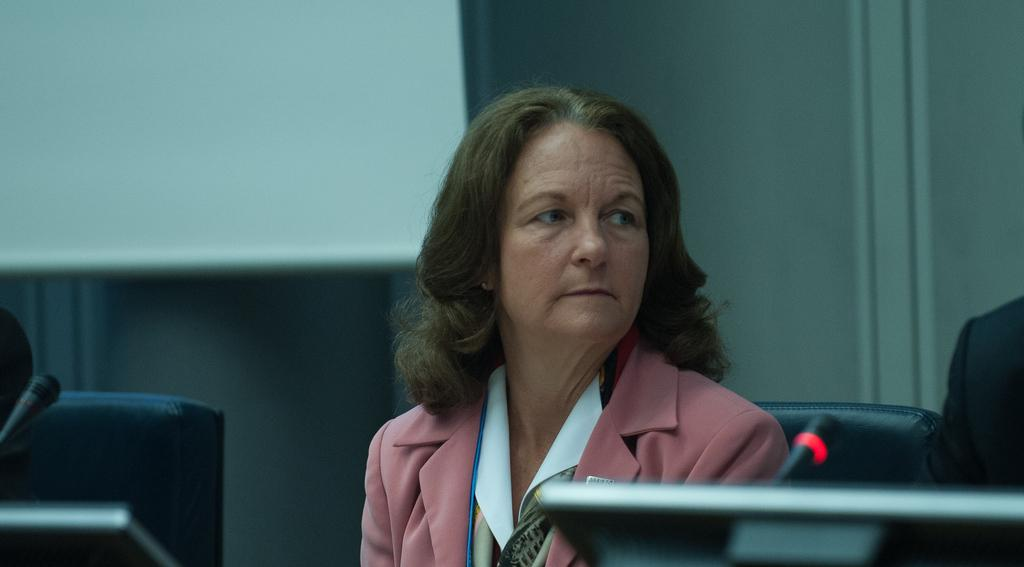What is the person in the image doing? The person is sitting in a room. What is the person sitting on? The person is sitting on a chair. What objects are on the table in the image? There is a microphone and laptops on the table. What can be seen on the wall in the room? There is a screen in the room. What type of bait is being used to catch fish in the image? There is no mention of fish or bait in the image; it features a person sitting in a room with a chair, a microphone, laptops, a screen, and a wall. 